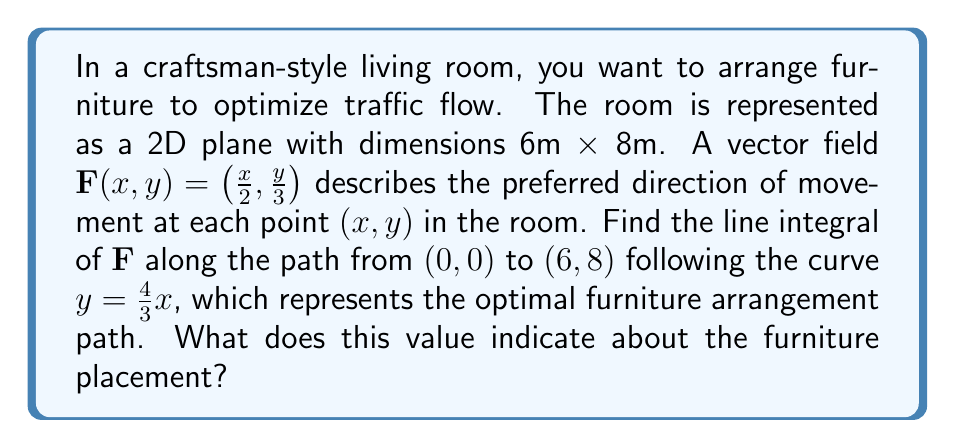Teach me how to tackle this problem. To solve this problem, we'll follow these steps:

1) The line integral along a curve $C$ is given by:
   $$\int_C \mathbf{F} \cdot d\mathbf{r} = \int_a^b \mathbf{F}(x(t),y(t)) \cdot \left(\frac{dx}{dt}, \frac{dy}{dt}\right) dt$$

2) Our curve is $y = \frac{4}{3}x$, which we can parametrize as:
   $x(t) = t$, $y(t) = \frac{4}{3}t$, where $0 \leq t \leq 6$

3) We need to find $\frac{dx}{dt}$ and $\frac{dy}{dt}$:
   $\frac{dx}{dt} = 1$, $\frac{dy}{dt} = \frac{4}{3}$

4) Our vector field is $\mathbf{F}(x,y) = \left(\frac{x}{2}, \frac{y}{3}\right)$

5) Substituting into the line integral formula:
   $$\int_0^6 \left(\frac{t}{2}, \frac{4t}{9}\right) \cdot (1, \frac{4}{3}) dt$$

6) Simplifying the dot product:
   $$\int_0^6 \left(\frac{t}{2} + \frac{16t}{27}\right) dt$$

7) Integrating:
   $$\left[\frac{t^2}{4} + \frac{8t^2}{27}\right]_0^6$$

8) Evaluating the bounds:
   $$\left(\frac{36}{4} + \frac{288}{27}\right) - (0 + 0) = 9 + \frac{32}{3} = 19.67$$

This value represents the total alignment of the furniture arrangement path with the preferred flow of movement in the room. A higher value indicates better alignment, suggesting that this arrangement facilitates smooth traffic flow in the craftsman-style living room.
Answer: 19.67 (indicating optimal furniture arrangement for traffic flow) 